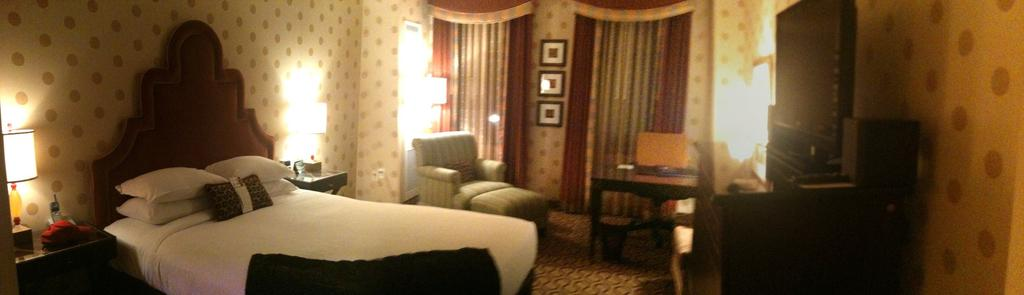What type of furniture is present in the image? There is a bed, a cot, a table, a lamp, a phone, a sofa, and photo frames in the image. What can be found on the bed? There are pillows on the bed. What is the purpose of the lamp in the image? The lamp is likely used for providing light in the room. What is covering the windows in the image? There are curtains covering the windows. What is the floor made of in the image? The floor is visible in the image, but the material is not specified. What type of chalk is being used to draw on the wall in the image? There is no chalk or drawing on the wall in the image. How many hens are sitting on the sofa in the image? There are no hens present in the image. 